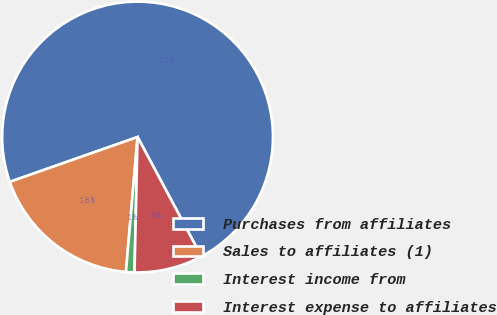Convert chart. <chart><loc_0><loc_0><loc_500><loc_500><pie_chart><fcel>Purchases from affiliates<fcel>Sales to affiliates (1)<fcel>Interest income from<fcel>Interest expense to affiliates<nl><fcel>72.55%<fcel>18.26%<fcel>1.01%<fcel>8.17%<nl></chart> 